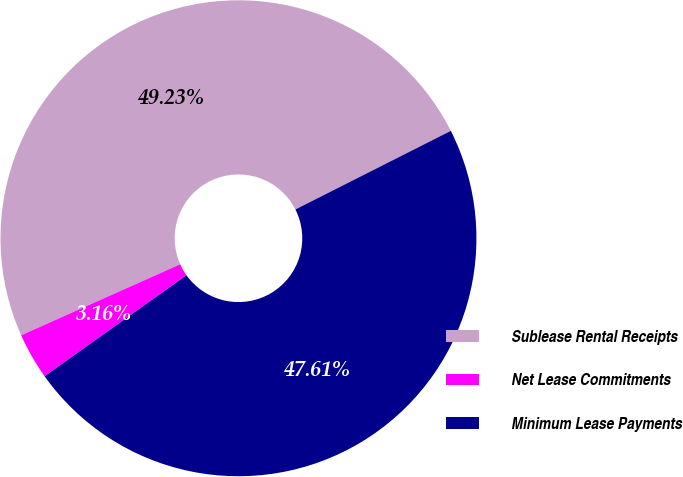Convert chart. <chart><loc_0><loc_0><loc_500><loc_500><pie_chart><fcel>Sublease Rental Receipts<fcel>Net Lease Commitments<fcel>Minimum Lease Payments<nl><fcel>49.23%<fcel>3.16%<fcel>47.61%<nl></chart> 